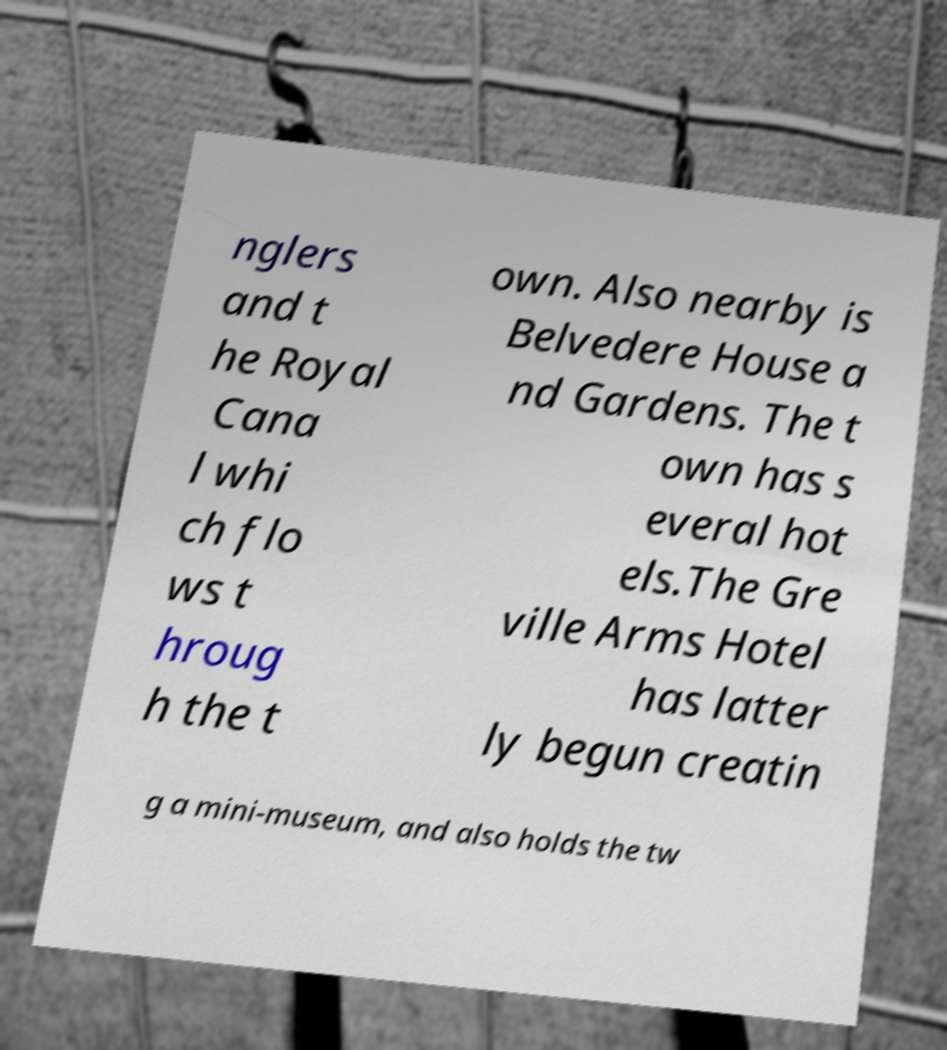Please identify and transcribe the text found in this image. nglers and t he Royal Cana l whi ch flo ws t hroug h the t own. Also nearby is Belvedere House a nd Gardens. The t own has s everal hot els.The Gre ville Arms Hotel has latter ly begun creatin g a mini-museum, and also holds the tw 